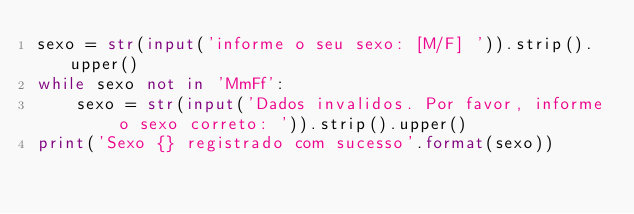<code> <loc_0><loc_0><loc_500><loc_500><_Python_>sexo = str(input('informe o seu sexo: [M/F] ')).strip().upper()
while sexo not in 'MmFf':
    sexo = str(input('Dados invalidos. Por favor, informe o sexo correto: ')).strip().upper()
print('Sexo {} registrado com sucesso'.format(sexo))
</code> 